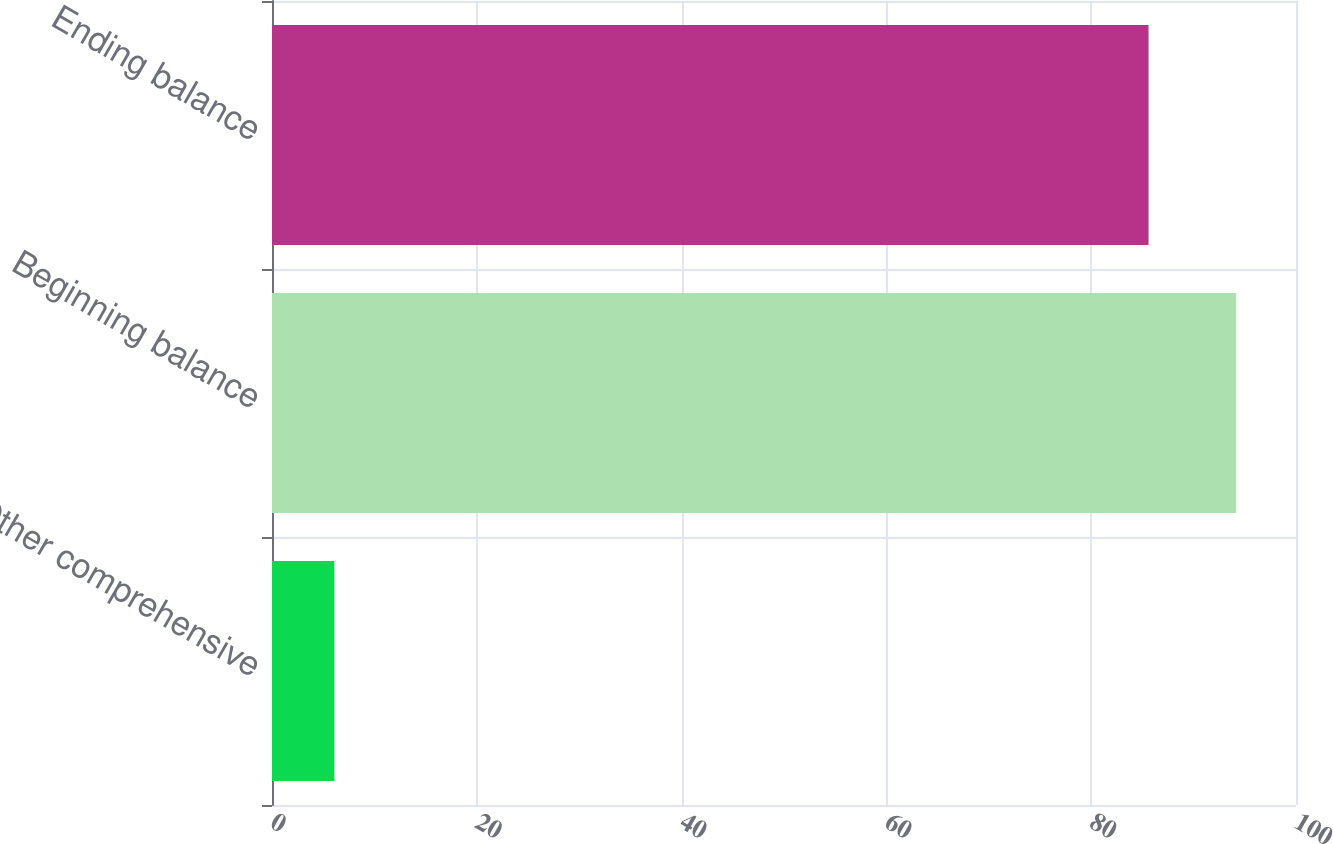Convert chart. <chart><loc_0><loc_0><loc_500><loc_500><bar_chart><fcel>Other comprehensive<fcel>Beginning balance<fcel>Ending balance<nl><fcel>6.1<fcel>94.16<fcel>85.6<nl></chart> 